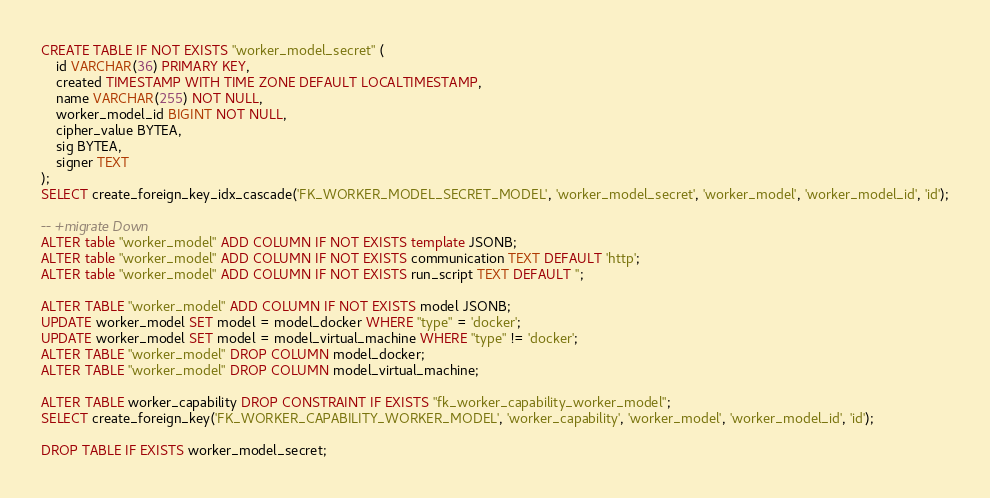<code> <loc_0><loc_0><loc_500><loc_500><_SQL_>CREATE TABLE IF NOT EXISTS "worker_model_secret" (
    id VARCHAR(36) PRIMARY KEY,
    created TIMESTAMP WITH TIME ZONE DEFAULT LOCALTIMESTAMP,
    name VARCHAR(255) NOT NULL,
    worker_model_id BIGINT NOT NULL,
    cipher_value BYTEA,
    sig BYTEA,
    signer TEXT
);
SELECT create_foreign_key_idx_cascade('FK_WORKER_MODEL_SECRET_MODEL', 'worker_model_secret', 'worker_model', 'worker_model_id', 'id');

-- +migrate Down
ALTER table "worker_model" ADD COLUMN IF NOT EXISTS template JSONB;
ALTER table "worker_model" ADD COLUMN IF NOT EXISTS communication TEXT DEFAULT 'http';
ALTER table "worker_model" ADD COLUMN IF NOT EXISTS run_script TEXT DEFAULT '';

ALTER TABLE "worker_model" ADD COLUMN IF NOT EXISTS model JSONB;
UPDATE worker_model SET model = model_docker WHERE "type" = 'docker';
UPDATE worker_model SET model = model_virtual_machine WHERE "type" != 'docker';
ALTER TABLE "worker_model" DROP COLUMN model_docker;
ALTER TABLE "worker_model" DROP COLUMN model_virtual_machine;

ALTER TABLE worker_capability DROP CONSTRAINT IF EXISTS "fk_worker_capability_worker_model";
SELECT create_foreign_key('FK_WORKER_CAPABILITY_WORKER_MODEL', 'worker_capability', 'worker_model', 'worker_model_id', 'id');

DROP TABLE IF EXISTS worker_model_secret;
</code> 